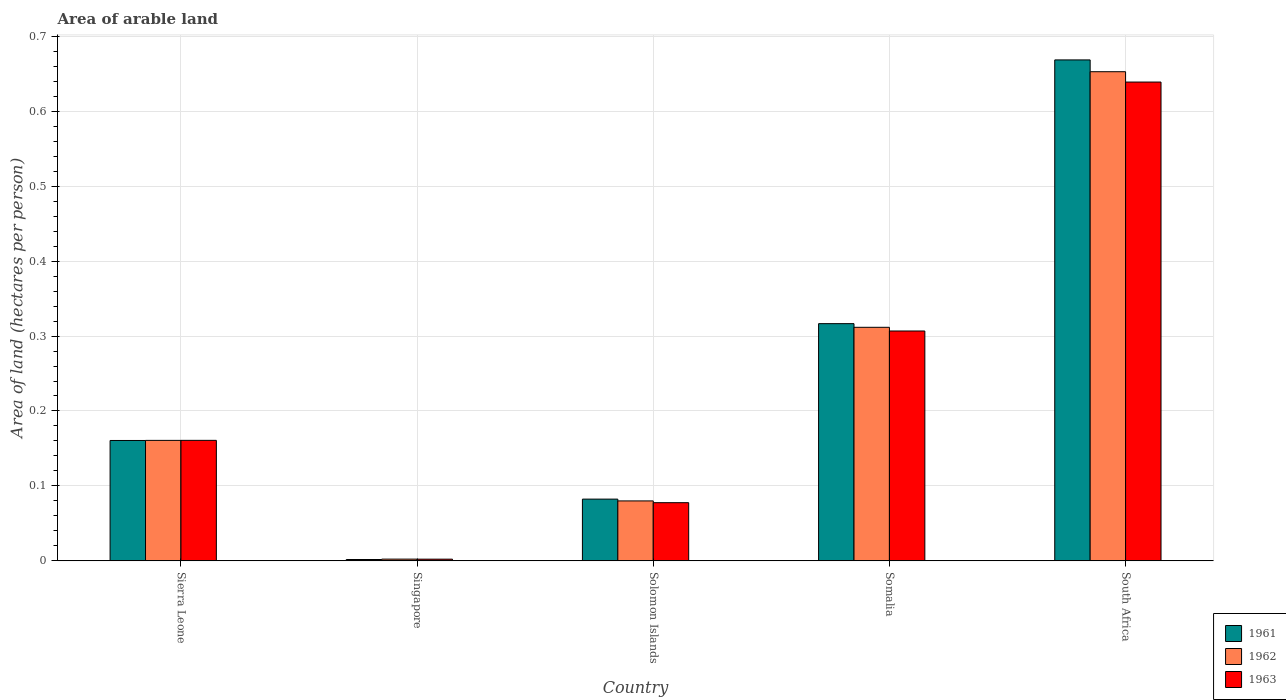Are the number of bars per tick equal to the number of legend labels?
Your answer should be very brief. Yes. Are the number of bars on each tick of the X-axis equal?
Offer a very short reply. Yes. How many bars are there on the 1st tick from the right?
Offer a terse response. 3. What is the label of the 2nd group of bars from the left?
Your answer should be compact. Singapore. What is the total arable land in 1961 in Somalia?
Ensure brevity in your answer.  0.32. Across all countries, what is the maximum total arable land in 1963?
Your answer should be very brief. 0.64. Across all countries, what is the minimum total arable land in 1961?
Provide a succinct answer. 0. In which country was the total arable land in 1963 maximum?
Keep it short and to the point. South Africa. In which country was the total arable land in 1963 minimum?
Provide a short and direct response. Singapore. What is the total total arable land in 1961 in the graph?
Offer a very short reply. 1.23. What is the difference between the total arable land in 1961 in Sierra Leone and that in Solomon Islands?
Your answer should be very brief. 0.08. What is the difference between the total arable land in 1962 in Solomon Islands and the total arable land in 1961 in Somalia?
Provide a short and direct response. -0.24. What is the average total arable land in 1962 per country?
Offer a terse response. 0.24. What is the difference between the total arable land of/in 1961 and total arable land of/in 1963 in Singapore?
Provide a succinct answer. -0. What is the ratio of the total arable land in 1963 in Singapore to that in Solomon Islands?
Make the answer very short. 0.03. Is the total arable land in 1963 in Singapore less than that in Somalia?
Make the answer very short. Yes. What is the difference between the highest and the second highest total arable land in 1961?
Your answer should be very brief. 0.35. What is the difference between the highest and the lowest total arable land in 1962?
Offer a very short reply. 0.65. In how many countries, is the total arable land in 1961 greater than the average total arable land in 1961 taken over all countries?
Ensure brevity in your answer.  2. Is the sum of the total arable land in 1961 in Sierra Leone and Solomon Islands greater than the maximum total arable land in 1963 across all countries?
Your answer should be very brief. No. What does the 2nd bar from the left in Somalia represents?
Provide a succinct answer. 1962. What does the 1st bar from the right in South Africa represents?
Offer a very short reply. 1963. Is it the case that in every country, the sum of the total arable land in 1962 and total arable land in 1961 is greater than the total arable land in 1963?
Your answer should be compact. Yes. Are all the bars in the graph horizontal?
Provide a short and direct response. No. What is the difference between two consecutive major ticks on the Y-axis?
Give a very brief answer. 0.1. Does the graph contain any zero values?
Provide a short and direct response. No. How many legend labels are there?
Provide a short and direct response. 3. How are the legend labels stacked?
Provide a short and direct response. Vertical. What is the title of the graph?
Your response must be concise. Area of arable land. Does "1984" appear as one of the legend labels in the graph?
Provide a succinct answer. No. What is the label or title of the Y-axis?
Ensure brevity in your answer.  Area of land (hectares per person). What is the Area of land (hectares per person) of 1961 in Sierra Leone?
Offer a very short reply. 0.16. What is the Area of land (hectares per person) in 1962 in Sierra Leone?
Offer a very short reply. 0.16. What is the Area of land (hectares per person) of 1963 in Sierra Leone?
Provide a succinct answer. 0.16. What is the Area of land (hectares per person) of 1961 in Singapore?
Make the answer very short. 0. What is the Area of land (hectares per person) in 1962 in Singapore?
Provide a short and direct response. 0. What is the Area of land (hectares per person) of 1963 in Singapore?
Offer a very short reply. 0. What is the Area of land (hectares per person) of 1961 in Solomon Islands?
Give a very brief answer. 0.08. What is the Area of land (hectares per person) of 1962 in Solomon Islands?
Your answer should be very brief. 0.08. What is the Area of land (hectares per person) of 1963 in Solomon Islands?
Make the answer very short. 0.08. What is the Area of land (hectares per person) in 1961 in Somalia?
Your response must be concise. 0.32. What is the Area of land (hectares per person) of 1962 in Somalia?
Make the answer very short. 0.31. What is the Area of land (hectares per person) in 1963 in Somalia?
Offer a terse response. 0.31. What is the Area of land (hectares per person) of 1961 in South Africa?
Offer a terse response. 0.67. What is the Area of land (hectares per person) of 1962 in South Africa?
Your answer should be compact. 0.65. What is the Area of land (hectares per person) in 1963 in South Africa?
Provide a succinct answer. 0.64. Across all countries, what is the maximum Area of land (hectares per person) in 1961?
Provide a succinct answer. 0.67. Across all countries, what is the maximum Area of land (hectares per person) of 1962?
Ensure brevity in your answer.  0.65. Across all countries, what is the maximum Area of land (hectares per person) in 1963?
Provide a succinct answer. 0.64. Across all countries, what is the minimum Area of land (hectares per person) in 1961?
Give a very brief answer. 0. Across all countries, what is the minimum Area of land (hectares per person) of 1962?
Provide a short and direct response. 0. Across all countries, what is the minimum Area of land (hectares per person) in 1963?
Give a very brief answer. 0. What is the total Area of land (hectares per person) of 1961 in the graph?
Offer a terse response. 1.23. What is the total Area of land (hectares per person) in 1962 in the graph?
Offer a terse response. 1.21. What is the total Area of land (hectares per person) in 1963 in the graph?
Provide a succinct answer. 1.19. What is the difference between the Area of land (hectares per person) in 1961 in Sierra Leone and that in Singapore?
Offer a terse response. 0.16. What is the difference between the Area of land (hectares per person) in 1962 in Sierra Leone and that in Singapore?
Offer a very short reply. 0.16. What is the difference between the Area of land (hectares per person) in 1963 in Sierra Leone and that in Singapore?
Give a very brief answer. 0.16. What is the difference between the Area of land (hectares per person) of 1961 in Sierra Leone and that in Solomon Islands?
Provide a short and direct response. 0.08. What is the difference between the Area of land (hectares per person) in 1962 in Sierra Leone and that in Solomon Islands?
Give a very brief answer. 0.08. What is the difference between the Area of land (hectares per person) of 1963 in Sierra Leone and that in Solomon Islands?
Offer a very short reply. 0.08. What is the difference between the Area of land (hectares per person) in 1961 in Sierra Leone and that in Somalia?
Offer a terse response. -0.16. What is the difference between the Area of land (hectares per person) in 1962 in Sierra Leone and that in Somalia?
Your response must be concise. -0.15. What is the difference between the Area of land (hectares per person) in 1963 in Sierra Leone and that in Somalia?
Offer a terse response. -0.15. What is the difference between the Area of land (hectares per person) in 1961 in Sierra Leone and that in South Africa?
Provide a succinct answer. -0.51. What is the difference between the Area of land (hectares per person) of 1962 in Sierra Leone and that in South Africa?
Offer a terse response. -0.49. What is the difference between the Area of land (hectares per person) in 1963 in Sierra Leone and that in South Africa?
Offer a very short reply. -0.48. What is the difference between the Area of land (hectares per person) in 1961 in Singapore and that in Solomon Islands?
Offer a terse response. -0.08. What is the difference between the Area of land (hectares per person) in 1962 in Singapore and that in Solomon Islands?
Give a very brief answer. -0.08. What is the difference between the Area of land (hectares per person) of 1963 in Singapore and that in Solomon Islands?
Your answer should be very brief. -0.08. What is the difference between the Area of land (hectares per person) of 1961 in Singapore and that in Somalia?
Your response must be concise. -0.31. What is the difference between the Area of land (hectares per person) in 1962 in Singapore and that in Somalia?
Offer a very short reply. -0.31. What is the difference between the Area of land (hectares per person) of 1963 in Singapore and that in Somalia?
Your answer should be very brief. -0.3. What is the difference between the Area of land (hectares per person) of 1961 in Singapore and that in South Africa?
Ensure brevity in your answer.  -0.67. What is the difference between the Area of land (hectares per person) in 1962 in Singapore and that in South Africa?
Your answer should be very brief. -0.65. What is the difference between the Area of land (hectares per person) in 1963 in Singapore and that in South Africa?
Keep it short and to the point. -0.64. What is the difference between the Area of land (hectares per person) in 1961 in Solomon Islands and that in Somalia?
Provide a succinct answer. -0.23. What is the difference between the Area of land (hectares per person) of 1962 in Solomon Islands and that in Somalia?
Your answer should be compact. -0.23. What is the difference between the Area of land (hectares per person) in 1963 in Solomon Islands and that in Somalia?
Make the answer very short. -0.23. What is the difference between the Area of land (hectares per person) in 1961 in Solomon Islands and that in South Africa?
Your response must be concise. -0.59. What is the difference between the Area of land (hectares per person) of 1962 in Solomon Islands and that in South Africa?
Give a very brief answer. -0.57. What is the difference between the Area of land (hectares per person) of 1963 in Solomon Islands and that in South Africa?
Your response must be concise. -0.56. What is the difference between the Area of land (hectares per person) of 1961 in Somalia and that in South Africa?
Provide a succinct answer. -0.35. What is the difference between the Area of land (hectares per person) of 1962 in Somalia and that in South Africa?
Your answer should be compact. -0.34. What is the difference between the Area of land (hectares per person) in 1963 in Somalia and that in South Africa?
Give a very brief answer. -0.33. What is the difference between the Area of land (hectares per person) in 1961 in Sierra Leone and the Area of land (hectares per person) in 1962 in Singapore?
Your response must be concise. 0.16. What is the difference between the Area of land (hectares per person) of 1961 in Sierra Leone and the Area of land (hectares per person) of 1963 in Singapore?
Ensure brevity in your answer.  0.16. What is the difference between the Area of land (hectares per person) in 1962 in Sierra Leone and the Area of land (hectares per person) in 1963 in Singapore?
Your answer should be very brief. 0.16. What is the difference between the Area of land (hectares per person) of 1961 in Sierra Leone and the Area of land (hectares per person) of 1962 in Solomon Islands?
Provide a short and direct response. 0.08. What is the difference between the Area of land (hectares per person) in 1961 in Sierra Leone and the Area of land (hectares per person) in 1963 in Solomon Islands?
Your answer should be very brief. 0.08. What is the difference between the Area of land (hectares per person) in 1962 in Sierra Leone and the Area of land (hectares per person) in 1963 in Solomon Islands?
Ensure brevity in your answer.  0.08. What is the difference between the Area of land (hectares per person) in 1961 in Sierra Leone and the Area of land (hectares per person) in 1962 in Somalia?
Provide a succinct answer. -0.15. What is the difference between the Area of land (hectares per person) of 1961 in Sierra Leone and the Area of land (hectares per person) of 1963 in Somalia?
Provide a short and direct response. -0.15. What is the difference between the Area of land (hectares per person) in 1962 in Sierra Leone and the Area of land (hectares per person) in 1963 in Somalia?
Ensure brevity in your answer.  -0.15. What is the difference between the Area of land (hectares per person) of 1961 in Sierra Leone and the Area of land (hectares per person) of 1962 in South Africa?
Your response must be concise. -0.49. What is the difference between the Area of land (hectares per person) in 1961 in Sierra Leone and the Area of land (hectares per person) in 1963 in South Africa?
Your answer should be very brief. -0.48. What is the difference between the Area of land (hectares per person) in 1962 in Sierra Leone and the Area of land (hectares per person) in 1963 in South Africa?
Keep it short and to the point. -0.48. What is the difference between the Area of land (hectares per person) of 1961 in Singapore and the Area of land (hectares per person) of 1962 in Solomon Islands?
Your response must be concise. -0.08. What is the difference between the Area of land (hectares per person) of 1961 in Singapore and the Area of land (hectares per person) of 1963 in Solomon Islands?
Ensure brevity in your answer.  -0.08. What is the difference between the Area of land (hectares per person) in 1962 in Singapore and the Area of land (hectares per person) in 1963 in Solomon Islands?
Make the answer very short. -0.08. What is the difference between the Area of land (hectares per person) of 1961 in Singapore and the Area of land (hectares per person) of 1962 in Somalia?
Your answer should be very brief. -0.31. What is the difference between the Area of land (hectares per person) of 1961 in Singapore and the Area of land (hectares per person) of 1963 in Somalia?
Provide a short and direct response. -0.3. What is the difference between the Area of land (hectares per person) of 1962 in Singapore and the Area of land (hectares per person) of 1963 in Somalia?
Keep it short and to the point. -0.3. What is the difference between the Area of land (hectares per person) in 1961 in Singapore and the Area of land (hectares per person) in 1962 in South Africa?
Provide a succinct answer. -0.65. What is the difference between the Area of land (hectares per person) of 1961 in Singapore and the Area of land (hectares per person) of 1963 in South Africa?
Your answer should be compact. -0.64. What is the difference between the Area of land (hectares per person) of 1962 in Singapore and the Area of land (hectares per person) of 1963 in South Africa?
Give a very brief answer. -0.64. What is the difference between the Area of land (hectares per person) in 1961 in Solomon Islands and the Area of land (hectares per person) in 1962 in Somalia?
Ensure brevity in your answer.  -0.23. What is the difference between the Area of land (hectares per person) of 1961 in Solomon Islands and the Area of land (hectares per person) of 1963 in Somalia?
Your answer should be compact. -0.22. What is the difference between the Area of land (hectares per person) in 1962 in Solomon Islands and the Area of land (hectares per person) in 1963 in Somalia?
Offer a terse response. -0.23. What is the difference between the Area of land (hectares per person) in 1961 in Solomon Islands and the Area of land (hectares per person) in 1962 in South Africa?
Keep it short and to the point. -0.57. What is the difference between the Area of land (hectares per person) in 1961 in Solomon Islands and the Area of land (hectares per person) in 1963 in South Africa?
Make the answer very short. -0.56. What is the difference between the Area of land (hectares per person) in 1962 in Solomon Islands and the Area of land (hectares per person) in 1963 in South Africa?
Offer a very short reply. -0.56. What is the difference between the Area of land (hectares per person) in 1961 in Somalia and the Area of land (hectares per person) in 1962 in South Africa?
Provide a succinct answer. -0.34. What is the difference between the Area of land (hectares per person) in 1961 in Somalia and the Area of land (hectares per person) in 1963 in South Africa?
Provide a short and direct response. -0.32. What is the difference between the Area of land (hectares per person) of 1962 in Somalia and the Area of land (hectares per person) of 1963 in South Africa?
Your answer should be very brief. -0.33. What is the average Area of land (hectares per person) in 1961 per country?
Make the answer very short. 0.25. What is the average Area of land (hectares per person) of 1962 per country?
Keep it short and to the point. 0.24. What is the average Area of land (hectares per person) of 1963 per country?
Keep it short and to the point. 0.24. What is the difference between the Area of land (hectares per person) of 1961 and Area of land (hectares per person) of 1962 in Sierra Leone?
Provide a short and direct response. -0. What is the difference between the Area of land (hectares per person) of 1961 and Area of land (hectares per person) of 1963 in Sierra Leone?
Provide a short and direct response. -0. What is the difference between the Area of land (hectares per person) in 1962 and Area of land (hectares per person) in 1963 in Sierra Leone?
Your answer should be very brief. -0. What is the difference between the Area of land (hectares per person) in 1961 and Area of land (hectares per person) in 1962 in Singapore?
Your response must be concise. -0. What is the difference between the Area of land (hectares per person) of 1961 and Area of land (hectares per person) of 1963 in Singapore?
Provide a short and direct response. -0. What is the difference between the Area of land (hectares per person) of 1961 and Area of land (hectares per person) of 1962 in Solomon Islands?
Keep it short and to the point. 0. What is the difference between the Area of land (hectares per person) in 1961 and Area of land (hectares per person) in 1963 in Solomon Islands?
Your response must be concise. 0. What is the difference between the Area of land (hectares per person) in 1962 and Area of land (hectares per person) in 1963 in Solomon Islands?
Your answer should be compact. 0. What is the difference between the Area of land (hectares per person) in 1961 and Area of land (hectares per person) in 1962 in Somalia?
Your answer should be very brief. 0. What is the difference between the Area of land (hectares per person) in 1961 and Area of land (hectares per person) in 1963 in Somalia?
Give a very brief answer. 0.01. What is the difference between the Area of land (hectares per person) in 1962 and Area of land (hectares per person) in 1963 in Somalia?
Provide a short and direct response. 0. What is the difference between the Area of land (hectares per person) in 1961 and Area of land (hectares per person) in 1962 in South Africa?
Provide a succinct answer. 0.02. What is the difference between the Area of land (hectares per person) of 1961 and Area of land (hectares per person) of 1963 in South Africa?
Your response must be concise. 0.03. What is the difference between the Area of land (hectares per person) of 1962 and Area of land (hectares per person) of 1963 in South Africa?
Offer a very short reply. 0.01. What is the ratio of the Area of land (hectares per person) of 1961 in Sierra Leone to that in Singapore?
Offer a terse response. 91.15. What is the ratio of the Area of land (hectares per person) in 1962 in Sierra Leone to that in Singapore?
Provide a short and direct response. 70.33. What is the ratio of the Area of land (hectares per person) of 1963 in Sierra Leone to that in Singapore?
Offer a terse response. 72.16. What is the ratio of the Area of land (hectares per person) of 1961 in Sierra Leone to that in Solomon Islands?
Provide a short and direct response. 1.95. What is the ratio of the Area of land (hectares per person) in 1962 in Sierra Leone to that in Solomon Islands?
Make the answer very short. 2.01. What is the ratio of the Area of land (hectares per person) in 1963 in Sierra Leone to that in Solomon Islands?
Give a very brief answer. 2.07. What is the ratio of the Area of land (hectares per person) in 1961 in Sierra Leone to that in Somalia?
Make the answer very short. 0.51. What is the ratio of the Area of land (hectares per person) of 1962 in Sierra Leone to that in Somalia?
Ensure brevity in your answer.  0.52. What is the ratio of the Area of land (hectares per person) of 1963 in Sierra Leone to that in Somalia?
Provide a succinct answer. 0.52. What is the ratio of the Area of land (hectares per person) in 1961 in Sierra Leone to that in South Africa?
Offer a very short reply. 0.24. What is the ratio of the Area of land (hectares per person) of 1962 in Sierra Leone to that in South Africa?
Offer a terse response. 0.25. What is the ratio of the Area of land (hectares per person) in 1963 in Sierra Leone to that in South Africa?
Your answer should be very brief. 0.25. What is the ratio of the Area of land (hectares per person) of 1961 in Singapore to that in Solomon Islands?
Your response must be concise. 0.02. What is the ratio of the Area of land (hectares per person) of 1962 in Singapore to that in Solomon Islands?
Provide a short and direct response. 0.03. What is the ratio of the Area of land (hectares per person) in 1963 in Singapore to that in Solomon Islands?
Offer a very short reply. 0.03. What is the ratio of the Area of land (hectares per person) in 1961 in Singapore to that in Somalia?
Provide a succinct answer. 0.01. What is the ratio of the Area of land (hectares per person) in 1962 in Singapore to that in Somalia?
Your answer should be very brief. 0.01. What is the ratio of the Area of land (hectares per person) of 1963 in Singapore to that in Somalia?
Your answer should be very brief. 0.01. What is the ratio of the Area of land (hectares per person) of 1961 in Singapore to that in South Africa?
Your answer should be very brief. 0. What is the ratio of the Area of land (hectares per person) in 1962 in Singapore to that in South Africa?
Provide a short and direct response. 0. What is the ratio of the Area of land (hectares per person) in 1963 in Singapore to that in South Africa?
Offer a terse response. 0. What is the ratio of the Area of land (hectares per person) of 1961 in Solomon Islands to that in Somalia?
Your answer should be compact. 0.26. What is the ratio of the Area of land (hectares per person) in 1962 in Solomon Islands to that in Somalia?
Provide a succinct answer. 0.26. What is the ratio of the Area of land (hectares per person) in 1963 in Solomon Islands to that in Somalia?
Keep it short and to the point. 0.25. What is the ratio of the Area of land (hectares per person) in 1961 in Solomon Islands to that in South Africa?
Offer a very short reply. 0.12. What is the ratio of the Area of land (hectares per person) of 1962 in Solomon Islands to that in South Africa?
Your response must be concise. 0.12. What is the ratio of the Area of land (hectares per person) of 1963 in Solomon Islands to that in South Africa?
Ensure brevity in your answer.  0.12. What is the ratio of the Area of land (hectares per person) of 1961 in Somalia to that in South Africa?
Offer a very short reply. 0.47. What is the ratio of the Area of land (hectares per person) of 1962 in Somalia to that in South Africa?
Make the answer very short. 0.48. What is the ratio of the Area of land (hectares per person) of 1963 in Somalia to that in South Africa?
Your response must be concise. 0.48. What is the difference between the highest and the second highest Area of land (hectares per person) in 1961?
Ensure brevity in your answer.  0.35. What is the difference between the highest and the second highest Area of land (hectares per person) of 1962?
Offer a very short reply. 0.34. What is the difference between the highest and the second highest Area of land (hectares per person) in 1963?
Your response must be concise. 0.33. What is the difference between the highest and the lowest Area of land (hectares per person) in 1961?
Make the answer very short. 0.67. What is the difference between the highest and the lowest Area of land (hectares per person) in 1962?
Ensure brevity in your answer.  0.65. What is the difference between the highest and the lowest Area of land (hectares per person) in 1963?
Keep it short and to the point. 0.64. 